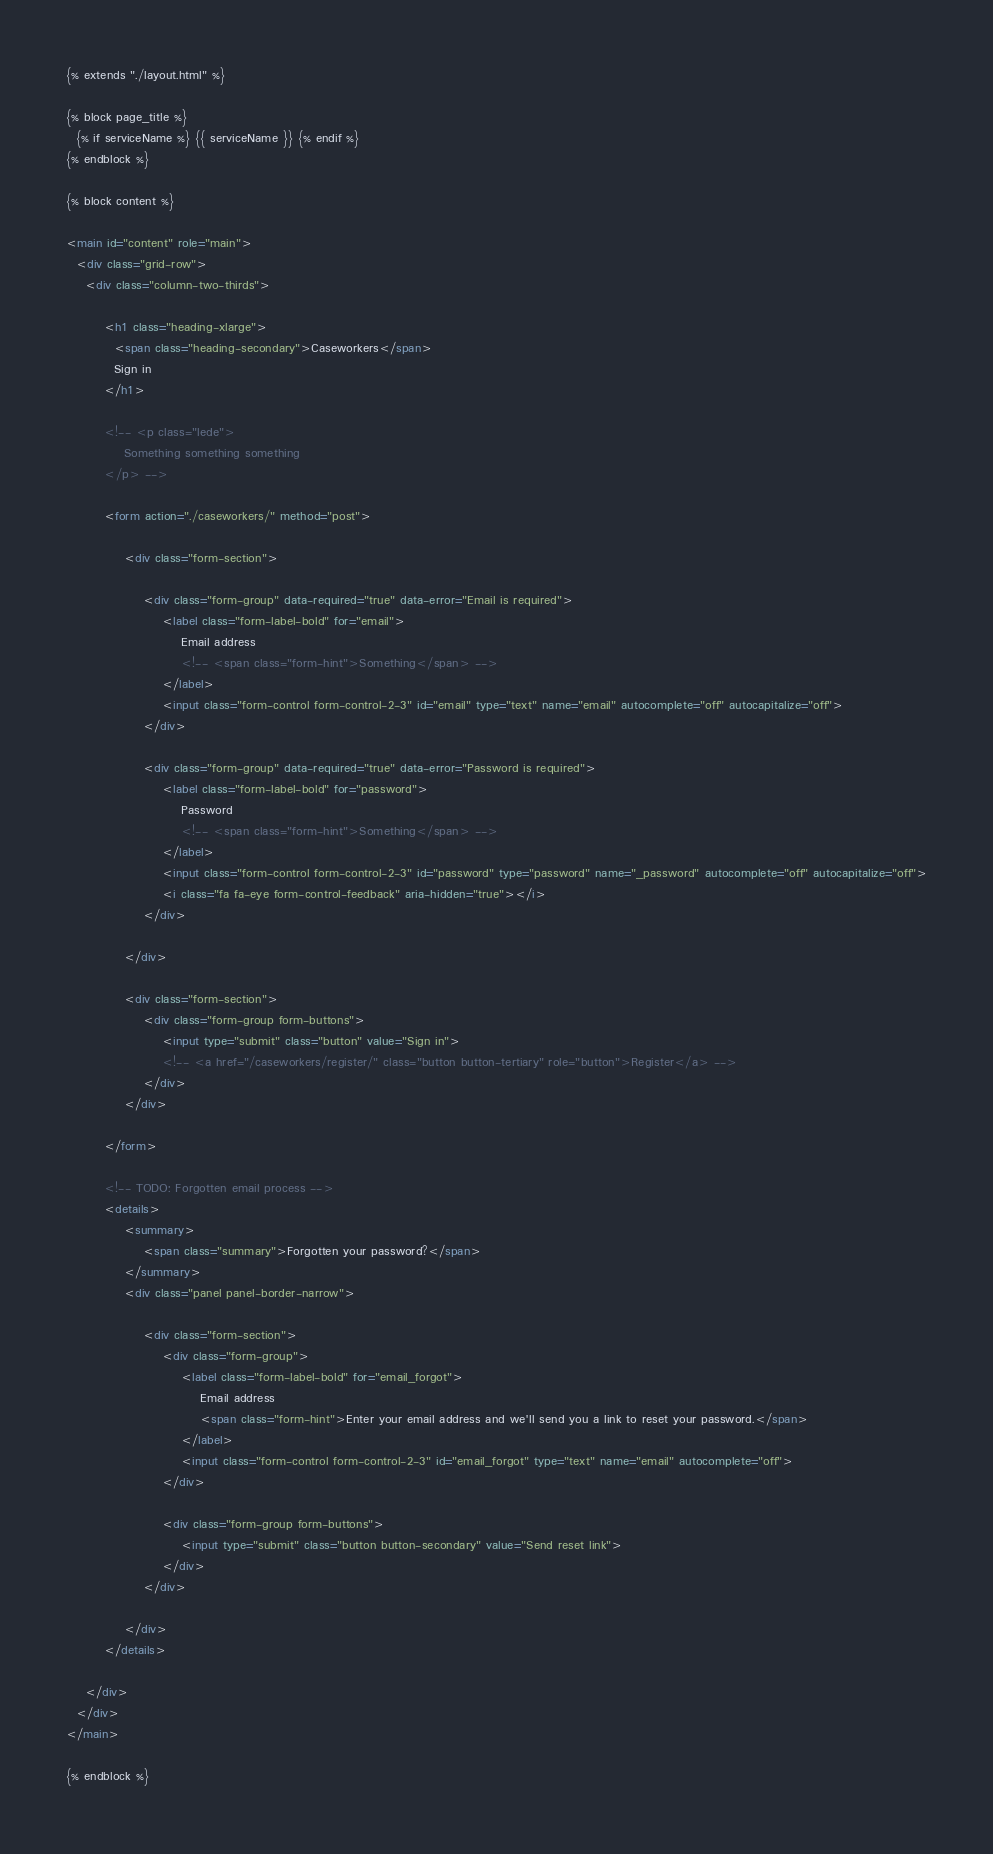<code> <loc_0><loc_0><loc_500><loc_500><_HTML_>{% extends "./layout.html" %}

{% block page_title %}
  {% if serviceName %} {{ serviceName }} {% endif %}
{% endblock %}

{% block content %}

<main id="content" role="main">
  <div class="grid-row">
    <div class="column-two-thirds">

		<h1 class="heading-xlarge">
	      <span class="heading-secondary">Caseworkers</span>
	      Sign in
	    </h1>

	    <!-- <p class="lede">
			Something something something
		</p> -->

	    <form action="./caseworkers/" method="post">

			<div class="form-section">
				
				<div class="form-group" data-required="true" data-error="Email is required">
					<label class="form-label-bold" for="email">
						Email address
						<!-- <span class="form-hint">Something</span> -->
					</label>
					<input class="form-control form-control-2-3" id="email" type="text" name="email" autocomplete="off" autocapitalize="off">
				</div>

				<div class="form-group" data-required="true" data-error="Password is required">
					<label class="form-label-bold" for="password">
						Password
						<!-- <span class="form-hint">Something</span> -->
					</label>
					<input class="form-control form-control-2-3" id="password" type="password" name="_password" autocomplete="off" autocapitalize="off">
					<i class="fa fa-eye form-control-feedback" aria-hidden="true"></i>
				</div>

			</div>

			<div class="form-section">
				<div class="form-group form-buttons">
					<input type="submit" class="button" value="Sign in">
					<!-- <a href="/caseworkers/register/" class="button button-tertiary" role="button">Register</a> -->
				</div>
			</div>

		</form>

		<!-- TODO: Forgotten email process -->
		<details>
			<summary>
				<span class="summary">Forgotten your password?</span>
			</summary>
			<div class="panel panel-border-narrow">

				<div class="form-section">
					<div class="form-group">
						<label class="form-label-bold" for="email_forgot">
							Email address
							<span class="form-hint">Enter your email address and we'll send you a link to reset your password.</span>
						</label>
						<input class="form-control form-control-2-3" id="email_forgot" type="text" name="email" autocomplete="off">
					</div>
				
					<div class="form-group form-buttons">
						<input type="submit" class="button button-secondary" value="Send reset link">
					</div>
				</div>

			</div>
		</details>

    </div>
  </div>
</main>

{% endblock %}</code> 